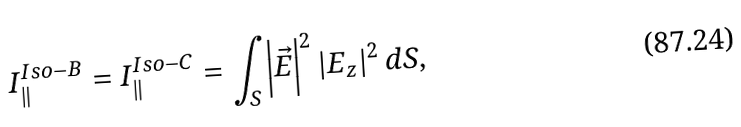<formula> <loc_0><loc_0><loc_500><loc_500>I _ { \| } ^ { I s o - B } = I _ { \| } ^ { I s o - C } = \int _ { S } \left | \vec { E } \right | ^ { 2 } \left | E _ { z } \right | ^ { 2 } d S ,</formula> 